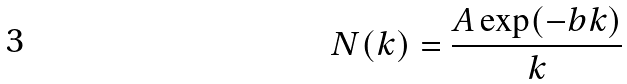Convert formula to latex. <formula><loc_0><loc_0><loc_500><loc_500>N ( k ) = \frac { A \exp ( - b k ) } { k }</formula> 